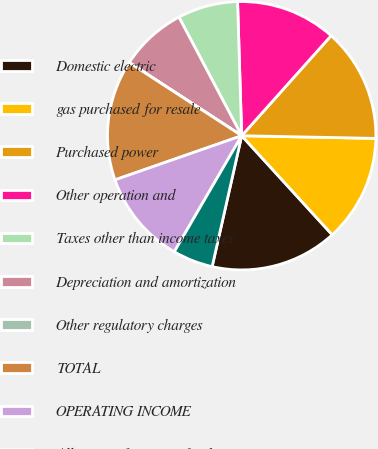Convert chart to OTSL. <chart><loc_0><loc_0><loc_500><loc_500><pie_chart><fcel>Domestic electric<fcel>gas purchased for resale<fcel>Purchased power<fcel>Other operation and<fcel>Taxes other than income taxes<fcel>Depreciation and amortization<fcel>Other regulatory charges<fcel>TOTAL<fcel>OPERATING INCOME<fcel>Allowance for equity funds<nl><fcel>15.32%<fcel>12.9%<fcel>13.71%<fcel>12.1%<fcel>7.26%<fcel>8.07%<fcel>0.01%<fcel>14.51%<fcel>11.29%<fcel>4.84%<nl></chart> 